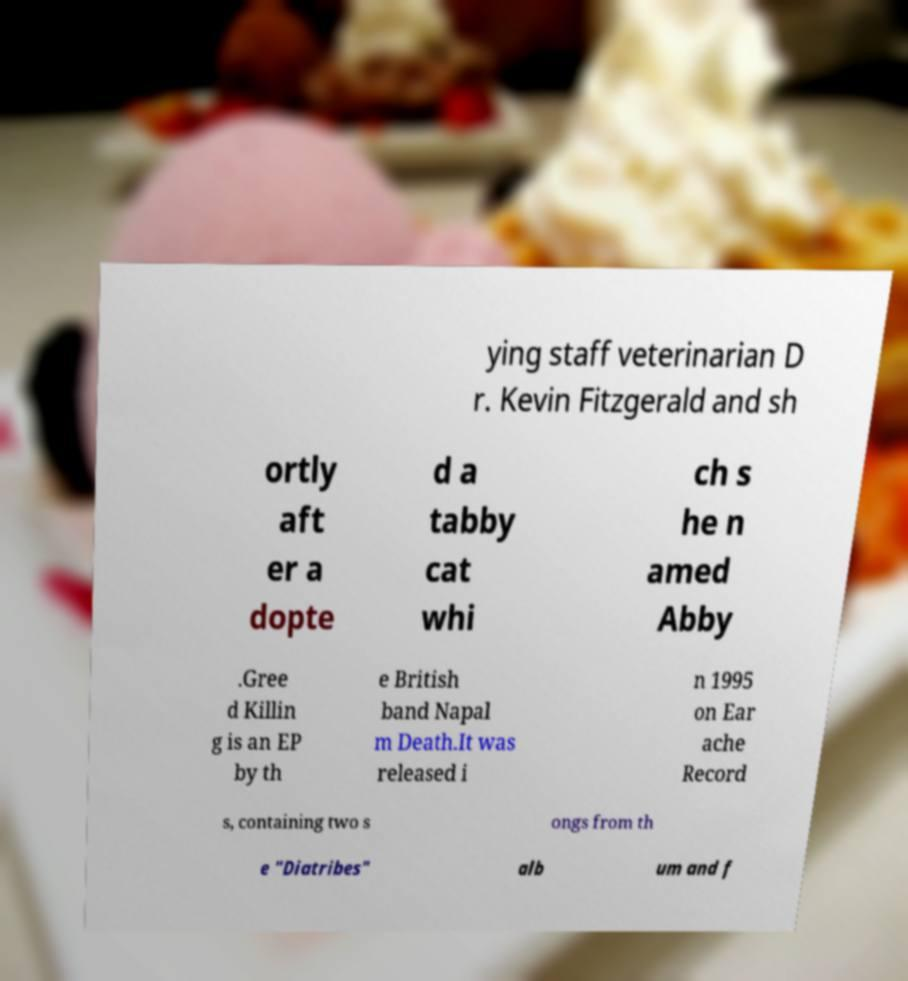There's text embedded in this image that I need extracted. Can you transcribe it verbatim? ying staff veterinarian D r. Kevin Fitzgerald and sh ortly aft er a dopte d a tabby cat whi ch s he n amed Abby .Gree d Killin g is an EP by th e British band Napal m Death.It was released i n 1995 on Ear ache Record s, containing two s ongs from th e "Diatribes" alb um and f 